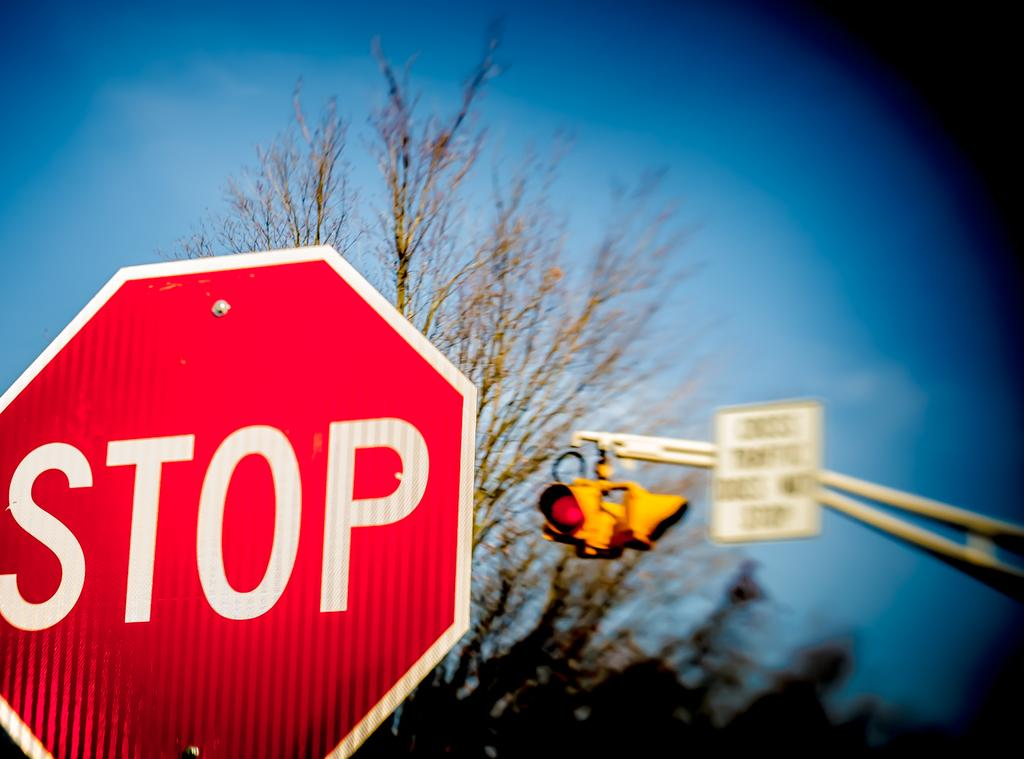Provide a one-sentence caption for the provided image. A red stop sign sits in front of a traffic light. 